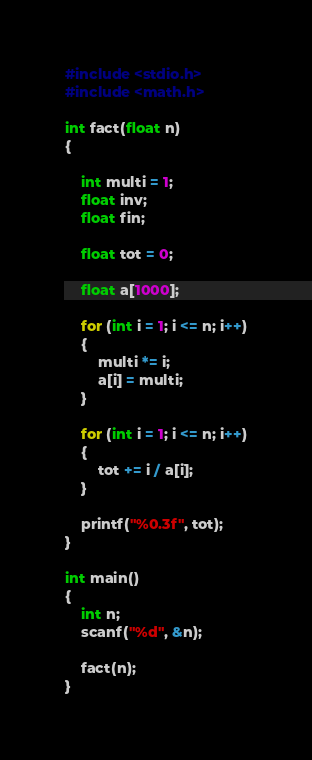<code> <loc_0><loc_0><loc_500><loc_500><_C_>#include <stdio.h>
#include <math.h>

int fact(float n)
{

    int multi = 1;
    float inv;
    float fin;

    float tot = 0;

    float a[1000];

    for (int i = 1; i <= n; i++)
    {
        multi *= i;
        a[i] = multi;
    }

    for (int i = 1; i <= n; i++)
    {
        tot += i / a[i];
    }

    printf("%0.3f", tot);
}

int main()
{
    int n;
    scanf("%d", &n);

    fact(n);
}</code> 